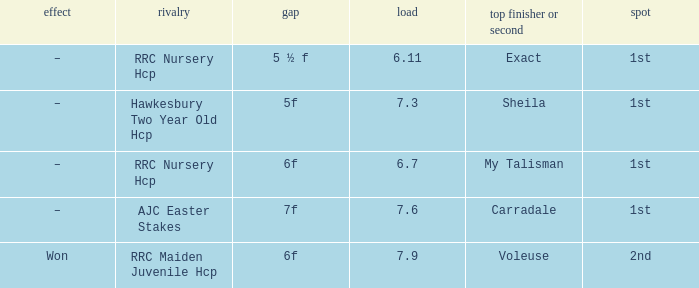What is the the name of the winner or 2nd  with a weight more than 7.3, and the result was –? Carradale. 